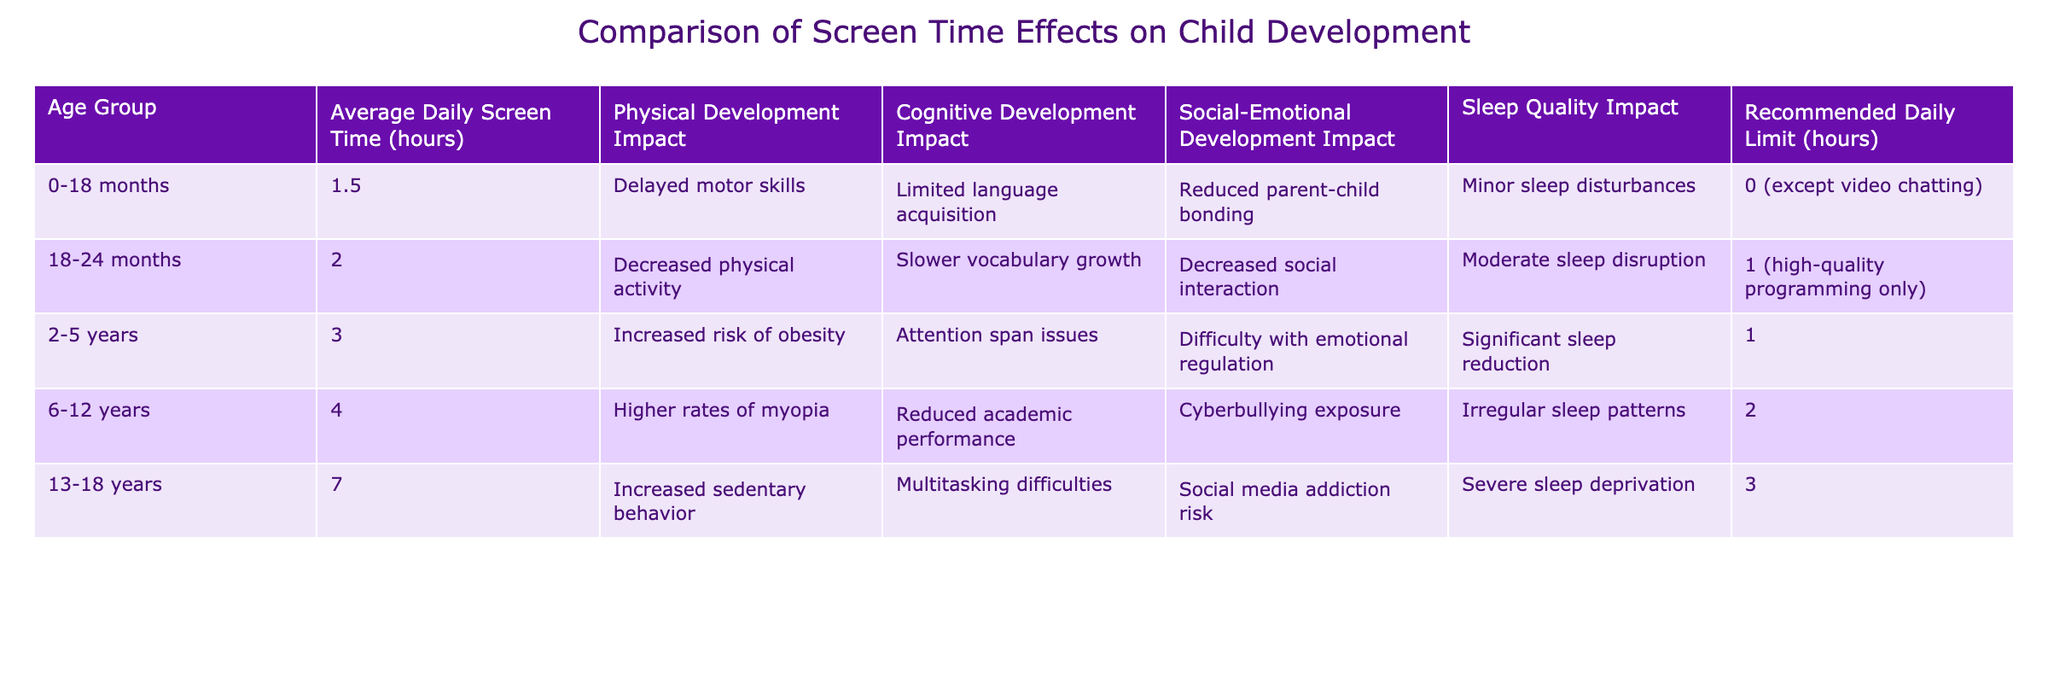What is the average daily screen time for the 6-12 years age group? The table shows that the average daily screen time for the 6-12 years age group is 4 hours.
Answer: 4 hours How many hours of screen time does the 13-18 years age group exceed the recommended daily limit? The recommended daily limit for the 13-18 years age group is 3 hours, while the average daily screen time is 7 hours. Therefore, 7 - 3 = 4 hours exceed the limit.
Answer: 4 hours Is it true that children aged 2-5 years have a risk of obesity due to increased screen time? Yes, the table states that the average daily screen time for the 2-5 years age group is 3 hours, which is associated with an increased risk of obesity.
Answer: Yes Which age group experiences significant sleep reduction due to screen time? The table indicates that children aged 2-5 years experience significant sleep reduction due to screen time.
Answer: 2-5 years What are the common impacts of screen time on cognitive development for children aged 6-12 years? According to the table, children aged 6-12 years experience reduced academic performance as a cognitive development impact due to screen time.
Answer: Reduced academic performance What is the total recommended daily limit for screen time across all age groups listed? The recommended daily limits for the age groups are: 0 for 0-18 months, 1 for 18-24 months, 1 for 2-5 years, 2 for 6-12 years, and 3 for 13-18 years. Adding these: 0 + 1 + 1 + 2 + 3 = 7 hours total.
Answer: 7 hours Which age group has the highest impact on social-emotional development and what is that impact? The table shows that the 13-18 years age group has a high risk of social media addiction as an impact on social-emotional development.
Answer: High risk of social media addiction How does the physical development impact of screen time change as children grow older? The impacts change as follows: for 0-18 months, it’s delayed motor skills; for 18-24 months, decreased physical activity; for 2-5 years, risk of obesity; for 6-12 years, higher rates of myopia; and for 13-18 years, increased sedentary behavior. This indicates a progression from motor skills delays to serious health issues related to inactivity.
Answer: Progresses from motor skills delays to serious health issues What is the impact of screen time on sleep quality for children aged 6-12 years? The table states that the impact of screen time on sleep quality for the 6-12 years age group is irregular sleep patterns.
Answer: Irregular sleep patterns 